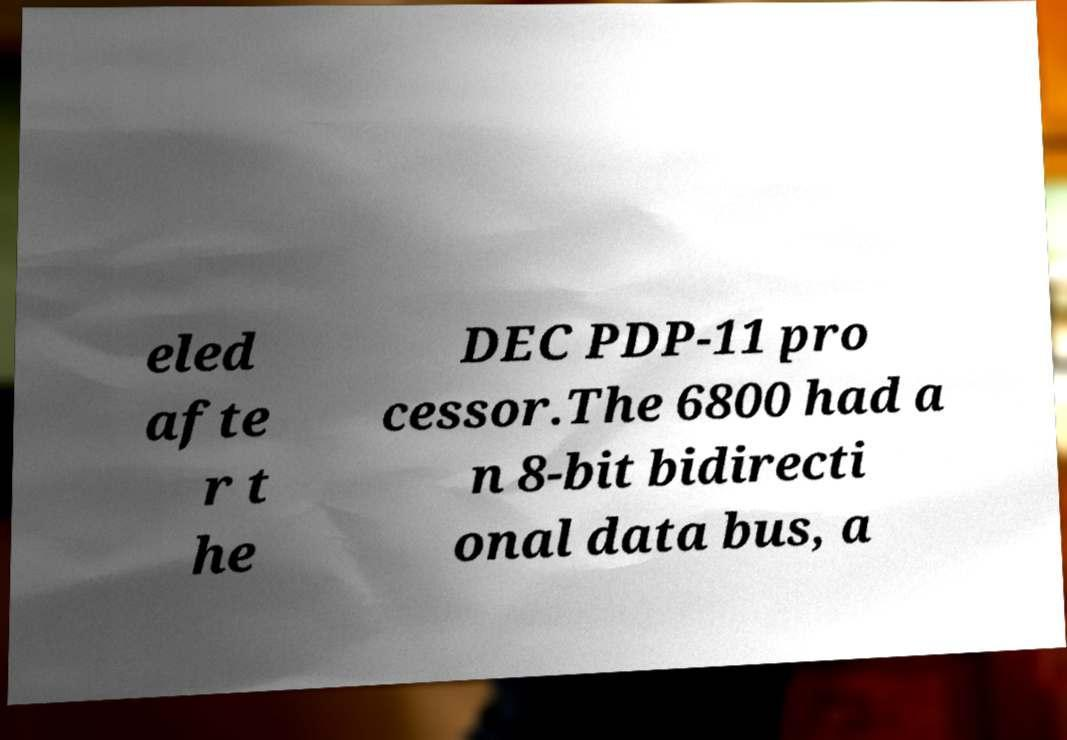I need the written content from this picture converted into text. Can you do that? eled afte r t he DEC PDP-11 pro cessor.The 6800 had a n 8-bit bidirecti onal data bus, a 